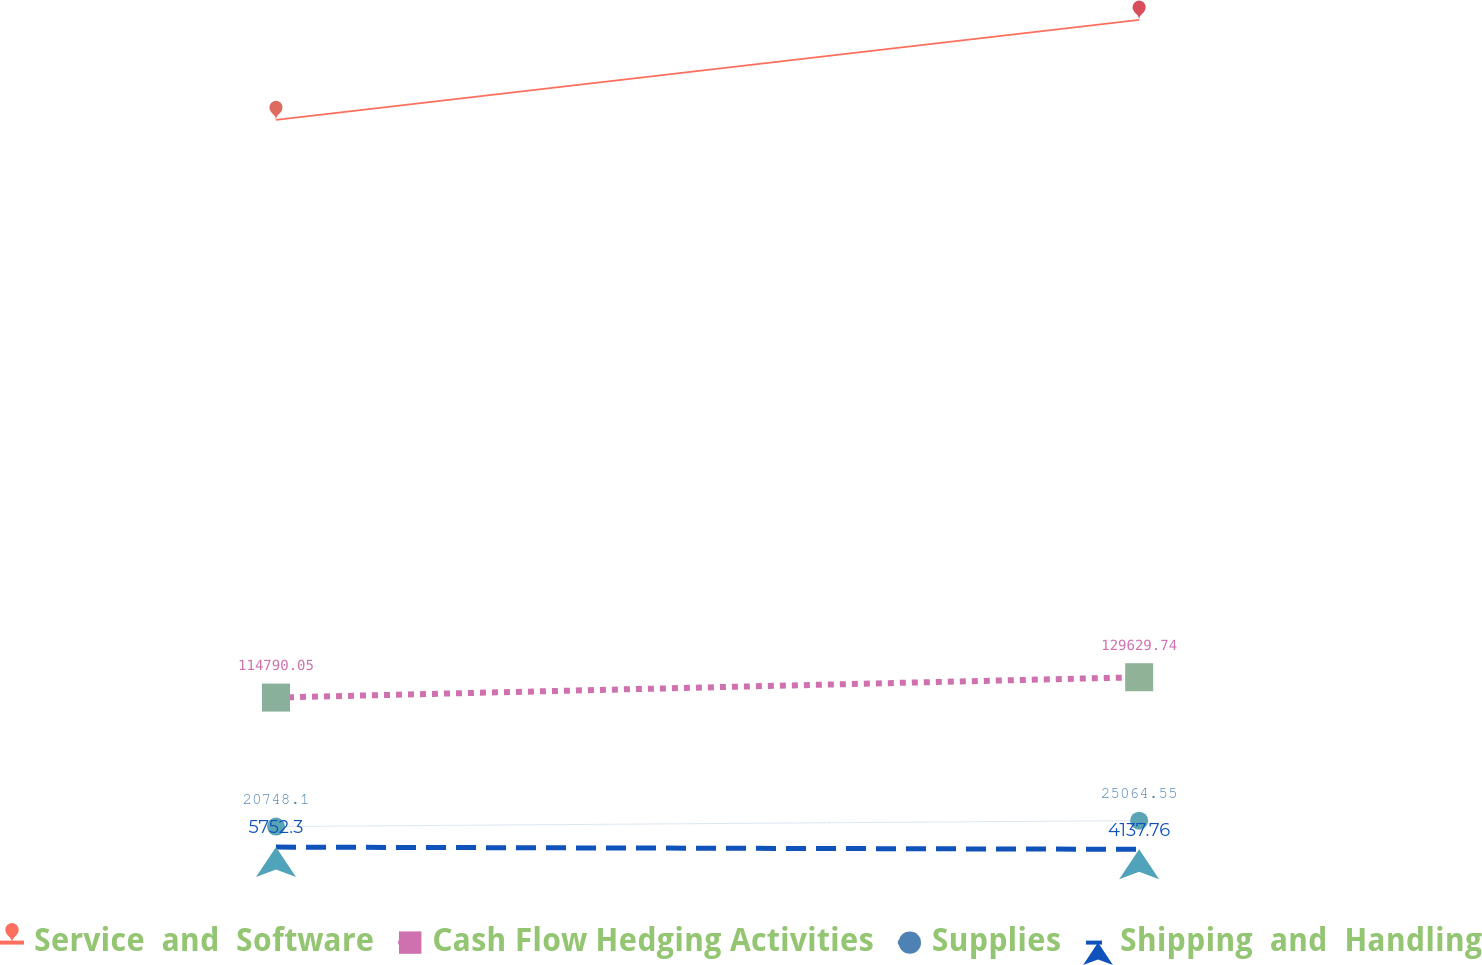Convert chart to OTSL. <chart><loc_0><loc_0><loc_500><loc_500><line_chart><ecel><fcel>Service  and  Software<fcel>Cash Flow Hedging Activities<fcel>Supplies<fcel>Shipping  and  Handling<nl><fcel>1631.97<fcel>535971<fcel>114790<fcel>20748.1<fcel>5752.3<nl><fcel>2087.63<fcel>608990<fcel>129630<fcel>25064.5<fcel>4137.76<nl><fcel>2307.68<fcel>457241<fcel>113141<fcel>21746.1<fcel>4299.21<nl></chart> 